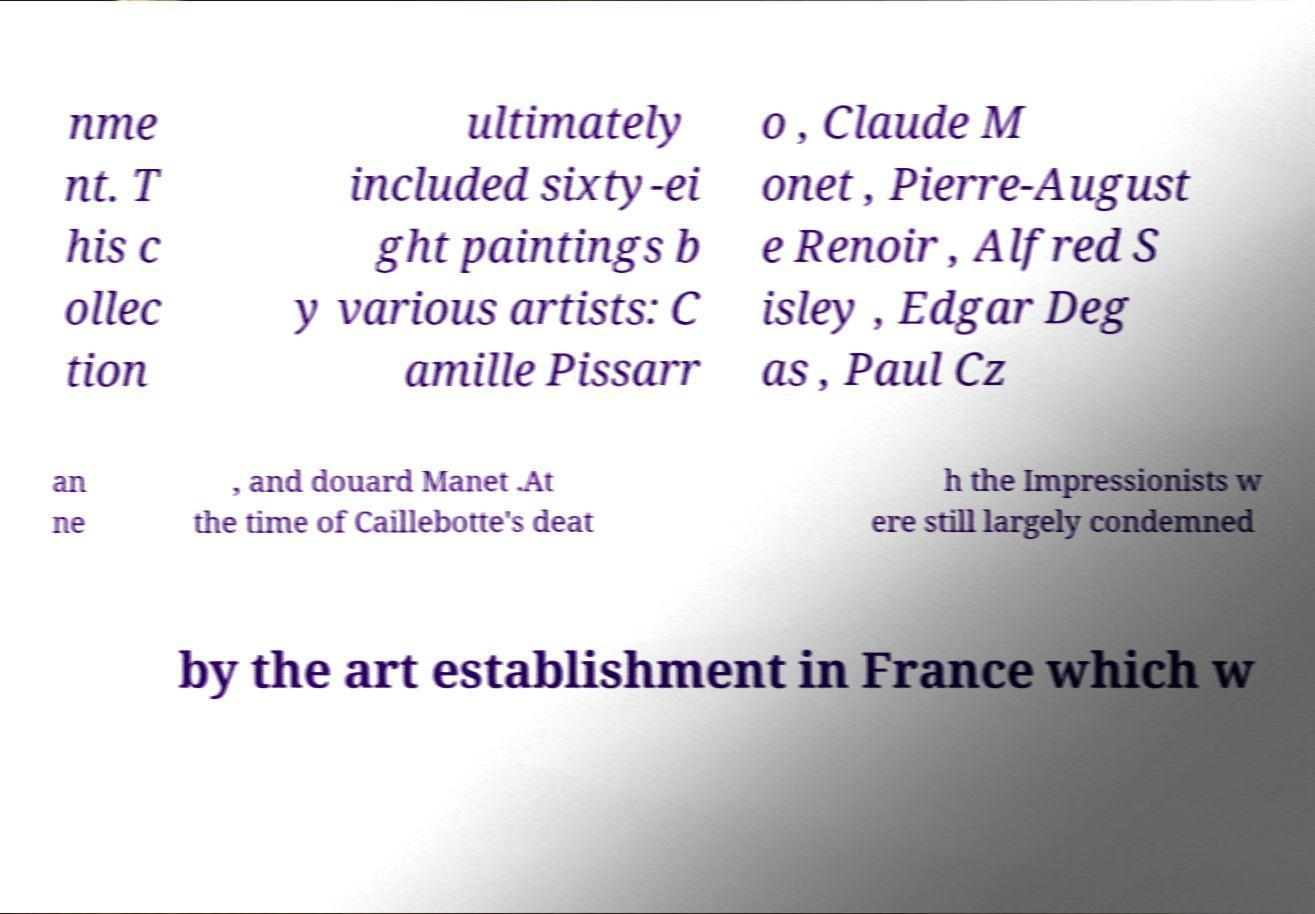What messages or text are displayed in this image? I need them in a readable, typed format. nme nt. T his c ollec tion ultimately included sixty-ei ght paintings b y various artists: C amille Pissarr o , Claude M onet , Pierre-August e Renoir , Alfred S isley , Edgar Deg as , Paul Cz an ne , and douard Manet .At the time of Caillebotte's deat h the Impressionists w ere still largely condemned by the art establishment in France which w 